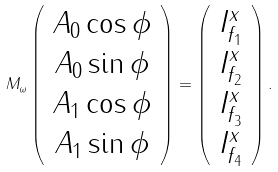Convert formula to latex. <formula><loc_0><loc_0><loc_500><loc_500>M _ { \omega } \left ( \begin{array} { c c c c } A _ { 0 } \cos \phi \\ A _ { 0 } \sin \phi \\ A _ { 1 } \cos \phi \\ A _ { 1 } \sin \phi \end{array} \right ) = \left ( \begin{array} { c c c c } I _ { f _ { 1 } } ^ { x } \\ I _ { f _ { 2 } } ^ { x } \\ I _ { f _ { 3 } } ^ { x } \\ I _ { f _ { 4 } } ^ { x } \end{array} \right ) .</formula> 